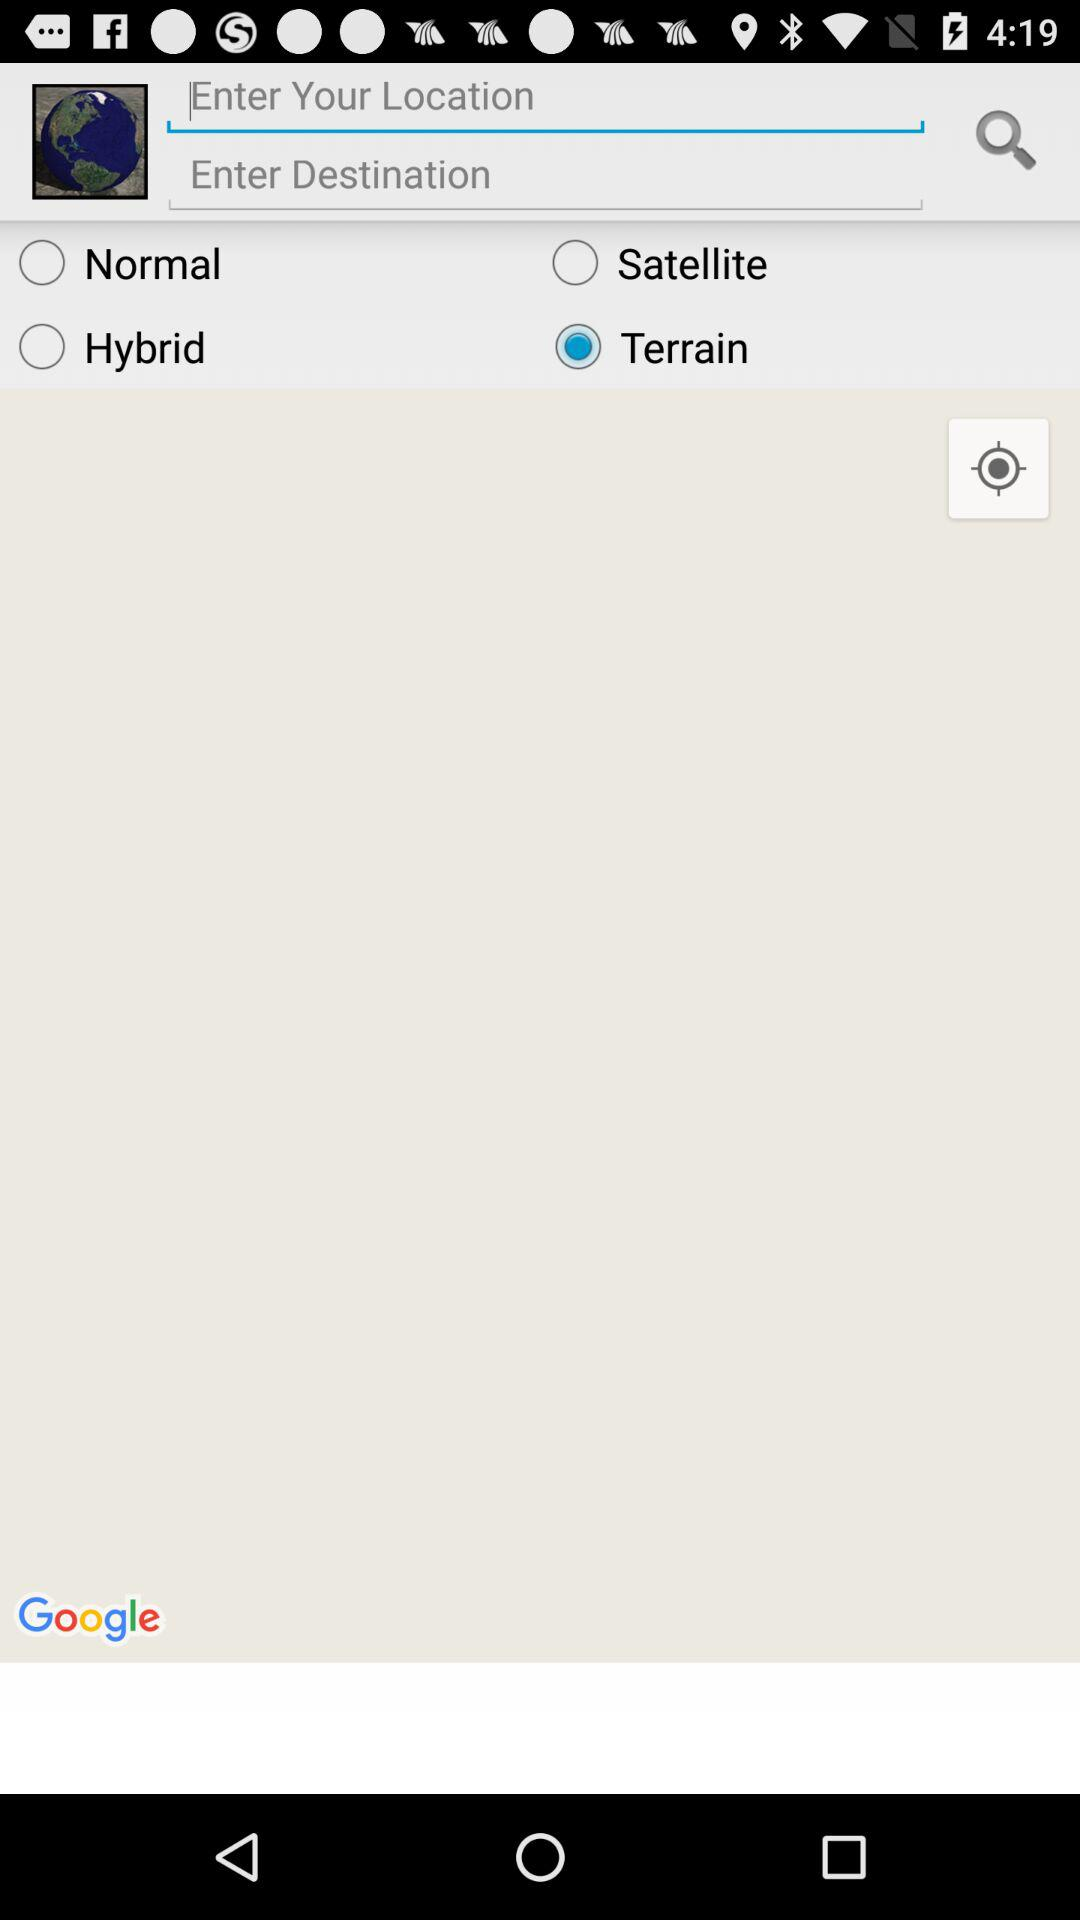Which option is selected? The selected option is "Terrain". 